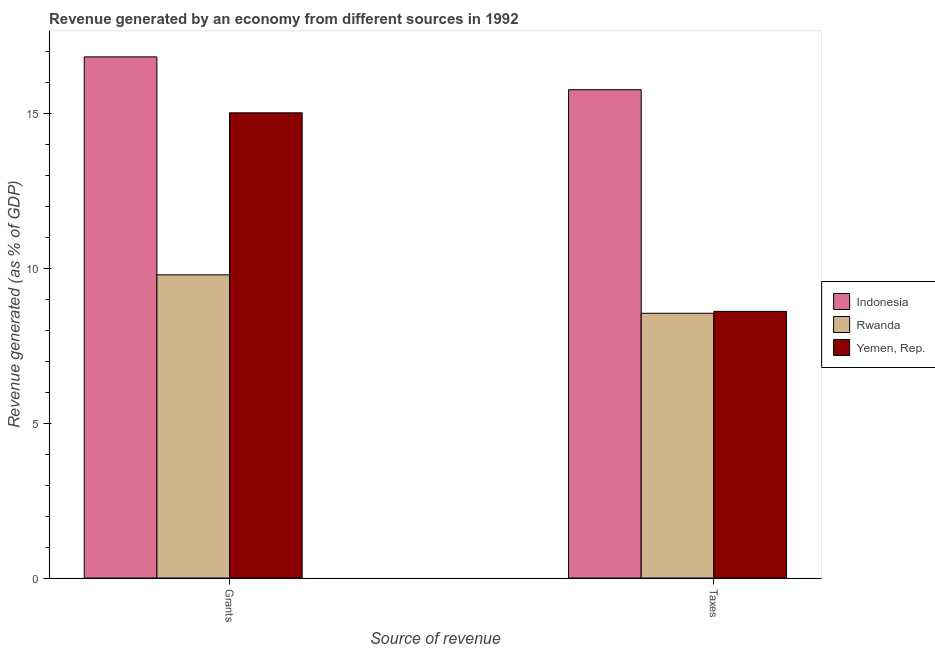How many different coloured bars are there?
Offer a very short reply. 3. How many bars are there on the 1st tick from the left?
Your response must be concise. 3. What is the label of the 1st group of bars from the left?
Ensure brevity in your answer.  Grants. What is the revenue generated by taxes in Yemen, Rep.?
Your answer should be compact. 8.61. Across all countries, what is the maximum revenue generated by grants?
Provide a succinct answer. 16.82. Across all countries, what is the minimum revenue generated by taxes?
Ensure brevity in your answer.  8.54. In which country was the revenue generated by taxes minimum?
Offer a very short reply. Rwanda. What is the total revenue generated by taxes in the graph?
Offer a very short reply. 32.91. What is the difference between the revenue generated by taxes in Rwanda and that in Yemen, Rep.?
Provide a succinct answer. -0.06. What is the difference between the revenue generated by grants in Indonesia and the revenue generated by taxes in Yemen, Rep.?
Your response must be concise. 8.21. What is the average revenue generated by taxes per country?
Make the answer very short. 10.97. What is the difference between the revenue generated by grants and revenue generated by taxes in Rwanda?
Provide a short and direct response. 1.24. In how many countries, is the revenue generated by taxes greater than 13 %?
Your response must be concise. 1. What is the ratio of the revenue generated by taxes in Yemen, Rep. to that in Indonesia?
Your answer should be very brief. 0.55. In how many countries, is the revenue generated by grants greater than the average revenue generated by grants taken over all countries?
Ensure brevity in your answer.  2. What does the 1st bar from the right in Taxes represents?
Offer a terse response. Yemen, Rep. How many countries are there in the graph?
Ensure brevity in your answer.  3. What is the difference between two consecutive major ticks on the Y-axis?
Ensure brevity in your answer.  5. Where does the legend appear in the graph?
Your answer should be very brief. Center right. How many legend labels are there?
Provide a short and direct response. 3. How are the legend labels stacked?
Offer a very short reply. Vertical. What is the title of the graph?
Offer a very short reply. Revenue generated by an economy from different sources in 1992. What is the label or title of the X-axis?
Your answer should be very brief. Source of revenue. What is the label or title of the Y-axis?
Give a very brief answer. Revenue generated (as % of GDP). What is the Revenue generated (as % of GDP) of Indonesia in Grants?
Provide a succinct answer. 16.82. What is the Revenue generated (as % of GDP) in Rwanda in Grants?
Offer a terse response. 9.78. What is the Revenue generated (as % of GDP) in Yemen, Rep. in Grants?
Your response must be concise. 15.01. What is the Revenue generated (as % of GDP) in Indonesia in Taxes?
Your response must be concise. 15.76. What is the Revenue generated (as % of GDP) of Rwanda in Taxes?
Offer a very short reply. 8.54. What is the Revenue generated (as % of GDP) in Yemen, Rep. in Taxes?
Your response must be concise. 8.61. Across all Source of revenue, what is the maximum Revenue generated (as % of GDP) of Indonesia?
Offer a very short reply. 16.82. Across all Source of revenue, what is the maximum Revenue generated (as % of GDP) in Rwanda?
Your answer should be compact. 9.78. Across all Source of revenue, what is the maximum Revenue generated (as % of GDP) in Yemen, Rep.?
Provide a succinct answer. 15.01. Across all Source of revenue, what is the minimum Revenue generated (as % of GDP) in Indonesia?
Your answer should be compact. 15.76. Across all Source of revenue, what is the minimum Revenue generated (as % of GDP) in Rwanda?
Ensure brevity in your answer.  8.54. Across all Source of revenue, what is the minimum Revenue generated (as % of GDP) of Yemen, Rep.?
Make the answer very short. 8.61. What is the total Revenue generated (as % of GDP) of Indonesia in the graph?
Ensure brevity in your answer.  32.58. What is the total Revenue generated (as % of GDP) in Rwanda in the graph?
Offer a terse response. 18.33. What is the total Revenue generated (as % of GDP) in Yemen, Rep. in the graph?
Give a very brief answer. 23.62. What is the difference between the Revenue generated (as % of GDP) of Indonesia in Grants and that in Taxes?
Provide a succinct answer. 1.06. What is the difference between the Revenue generated (as % of GDP) in Rwanda in Grants and that in Taxes?
Provide a short and direct response. 1.24. What is the difference between the Revenue generated (as % of GDP) in Yemen, Rep. in Grants and that in Taxes?
Make the answer very short. 6.41. What is the difference between the Revenue generated (as % of GDP) of Indonesia in Grants and the Revenue generated (as % of GDP) of Rwanda in Taxes?
Give a very brief answer. 8.27. What is the difference between the Revenue generated (as % of GDP) in Indonesia in Grants and the Revenue generated (as % of GDP) in Yemen, Rep. in Taxes?
Offer a very short reply. 8.21. What is the difference between the Revenue generated (as % of GDP) of Rwanda in Grants and the Revenue generated (as % of GDP) of Yemen, Rep. in Taxes?
Give a very brief answer. 1.18. What is the average Revenue generated (as % of GDP) in Indonesia per Source of revenue?
Provide a succinct answer. 16.29. What is the average Revenue generated (as % of GDP) in Rwanda per Source of revenue?
Your answer should be compact. 9.16. What is the average Revenue generated (as % of GDP) of Yemen, Rep. per Source of revenue?
Your answer should be very brief. 11.81. What is the difference between the Revenue generated (as % of GDP) of Indonesia and Revenue generated (as % of GDP) of Rwanda in Grants?
Offer a terse response. 7.03. What is the difference between the Revenue generated (as % of GDP) in Indonesia and Revenue generated (as % of GDP) in Yemen, Rep. in Grants?
Provide a short and direct response. 1.8. What is the difference between the Revenue generated (as % of GDP) in Rwanda and Revenue generated (as % of GDP) in Yemen, Rep. in Grants?
Ensure brevity in your answer.  -5.23. What is the difference between the Revenue generated (as % of GDP) in Indonesia and Revenue generated (as % of GDP) in Rwanda in Taxes?
Offer a terse response. 7.21. What is the difference between the Revenue generated (as % of GDP) of Indonesia and Revenue generated (as % of GDP) of Yemen, Rep. in Taxes?
Your answer should be compact. 7.15. What is the difference between the Revenue generated (as % of GDP) of Rwanda and Revenue generated (as % of GDP) of Yemen, Rep. in Taxes?
Your answer should be compact. -0.06. What is the ratio of the Revenue generated (as % of GDP) in Indonesia in Grants to that in Taxes?
Make the answer very short. 1.07. What is the ratio of the Revenue generated (as % of GDP) of Rwanda in Grants to that in Taxes?
Offer a terse response. 1.15. What is the ratio of the Revenue generated (as % of GDP) of Yemen, Rep. in Grants to that in Taxes?
Make the answer very short. 1.74. What is the difference between the highest and the second highest Revenue generated (as % of GDP) in Indonesia?
Make the answer very short. 1.06. What is the difference between the highest and the second highest Revenue generated (as % of GDP) in Rwanda?
Offer a very short reply. 1.24. What is the difference between the highest and the second highest Revenue generated (as % of GDP) of Yemen, Rep.?
Give a very brief answer. 6.41. What is the difference between the highest and the lowest Revenue generated (as % of GDP) in Indonesia?
Offer a terse response. 1.06. What is the difference between the highest and the lowest Revenue generated (as % of GDP) of Rwanda?
Your response must be concise. 1.24. What is the difference between the highest and the lowest Revenue generated (as % of GDP) in Yemen, Rep.?
Offer a terse response. 6.41. 